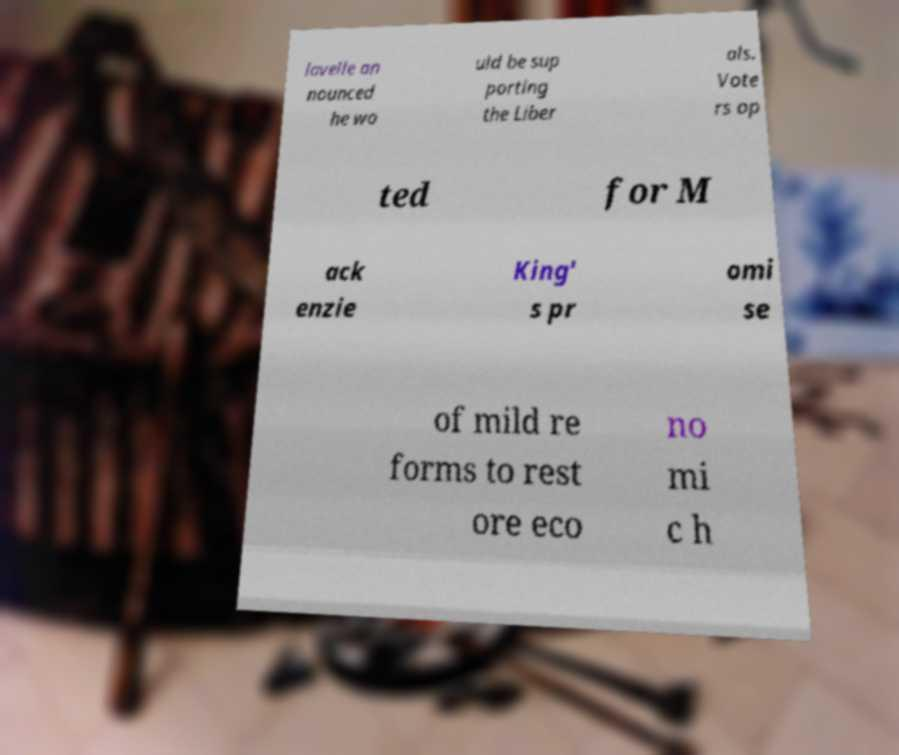Could you extract and type out the text from this image? lavelle an nounced he wo uld be sup porting the Liber als. Vote rs op ted for M ack enzie King' s pr omi se of mild re forms to rest ore eco no mi c h 